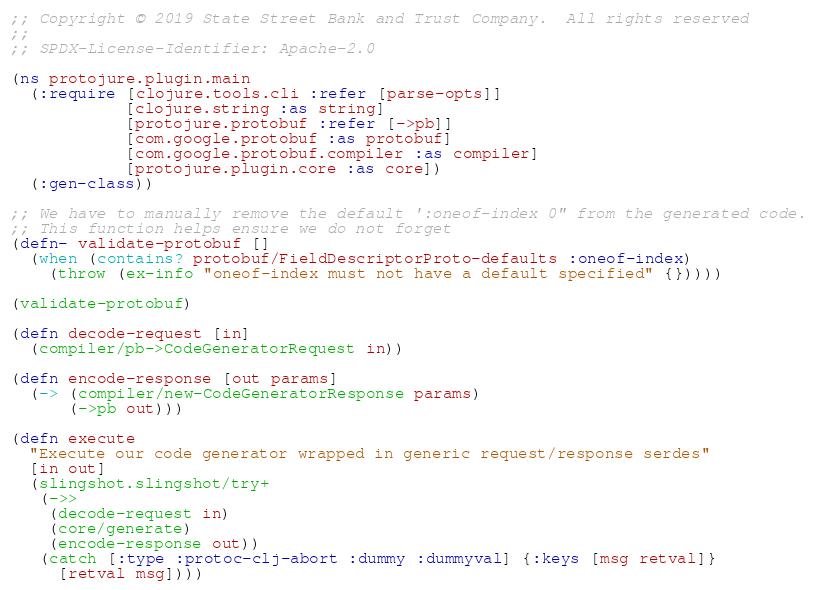<code> <loc_0><loc_0><loc_500><loc_500><_Clojure_>;; Copyright © 2019 State Street Bank and Trust Company.  All rights reserved
;;
;; SPDX-License-Identifier: Apache-2.0

(ns protojure.plugin.main
  (:require [clojure.tools.cli :refer [parse-opts]]
            [clojure.string :as string]
            [protojure.protobuf :refer [->pb]]
            [com.google.protobuf :as protobuf]
            [com.google.protobuf.compiler :as compiler]
            [protojure.plugin.core :as core])
  (:gen-class))

;; We have to manually remove the default ':oneof-index 0" from the generated code.
;; This function helps ensure we do not forget
(defn- validate-protobuf []
  (when (contains? protobuf/FieldDescriptorProto-defaults :oneof-index)
    (throw (ex-info "oneof-index must not have a default specified" {}))))

(validate-protobuf)

(defn decode-request [in]
  (compiler/pb->CodeGeneratorRequest in))

(defn encode-response [out params]
  (-> (compiler/new-CodeGeneratorResponse params)
      (->pb out)))

(defn execute
  "Execute our code generator wrapped in generic request/response serdes"
  [in out]
  (slingshot.slingshot/try+
   (->>
    (decode-request in)
    (core/generate)
    (encode-response out))
   (catch [:type :protoc-clj-abort :dummy :dummyval] {:keys [msg retval]}
     [retval msg])))
</code> 